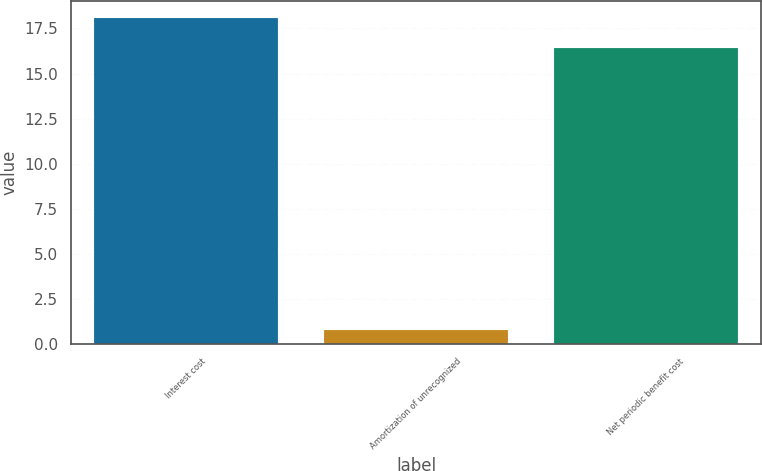Convert chart to OTSL. <chart><loc_0><loc_0><loc_500><loc_500><bar_chart><fcel>Interest cost<fcel>Amortization of unrecognized<fcel>Net periodic benefit cost<nl><fcel>18.1<fcel>0.8<fcel>16.4<nl></chart> 